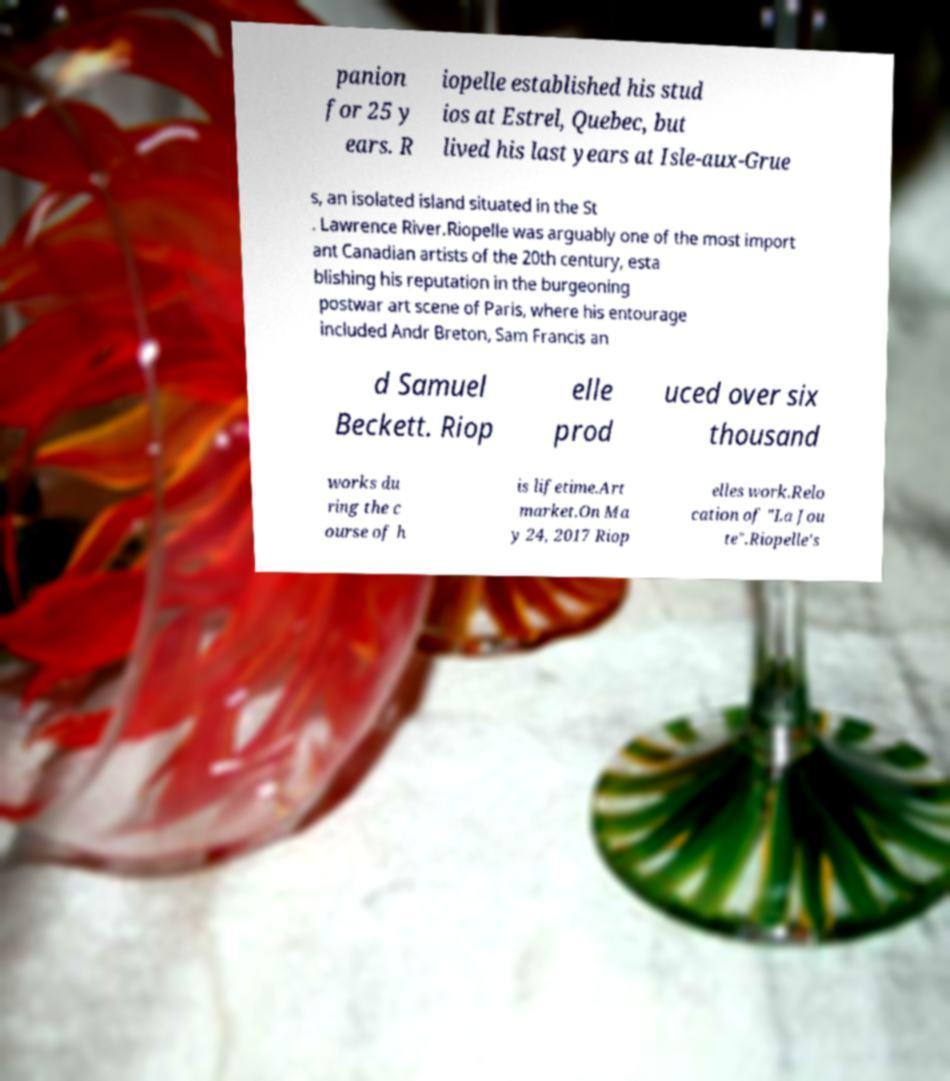Can you accurately transcribe the text from the provided image for me? panion for 25 y ears. R iopelle established his stud ios at Estrel, Quebec, but lived his last years at Isle-aux-Grue s, an isolated island situated in the St . Lawrence River.Riopelle was arguably one of the most import ant Canadian artists of the 20th century, esta blishing his reputation in the burgeoning postwar art scene of Paris, where his entourage included Andr Breton, Sam Francis an d Samuel Beckett. Riop elle prod uced over six thousand works du ring the c ourse of h is lifetime.Art market.On Ma y 24, 2017 Riop elles work.Relo cation of "La Jou te".Riopelle's 